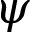Convert formula to latex. <formula><loc_0><loc_0><loc_500><loc_500>\psi</formula> 